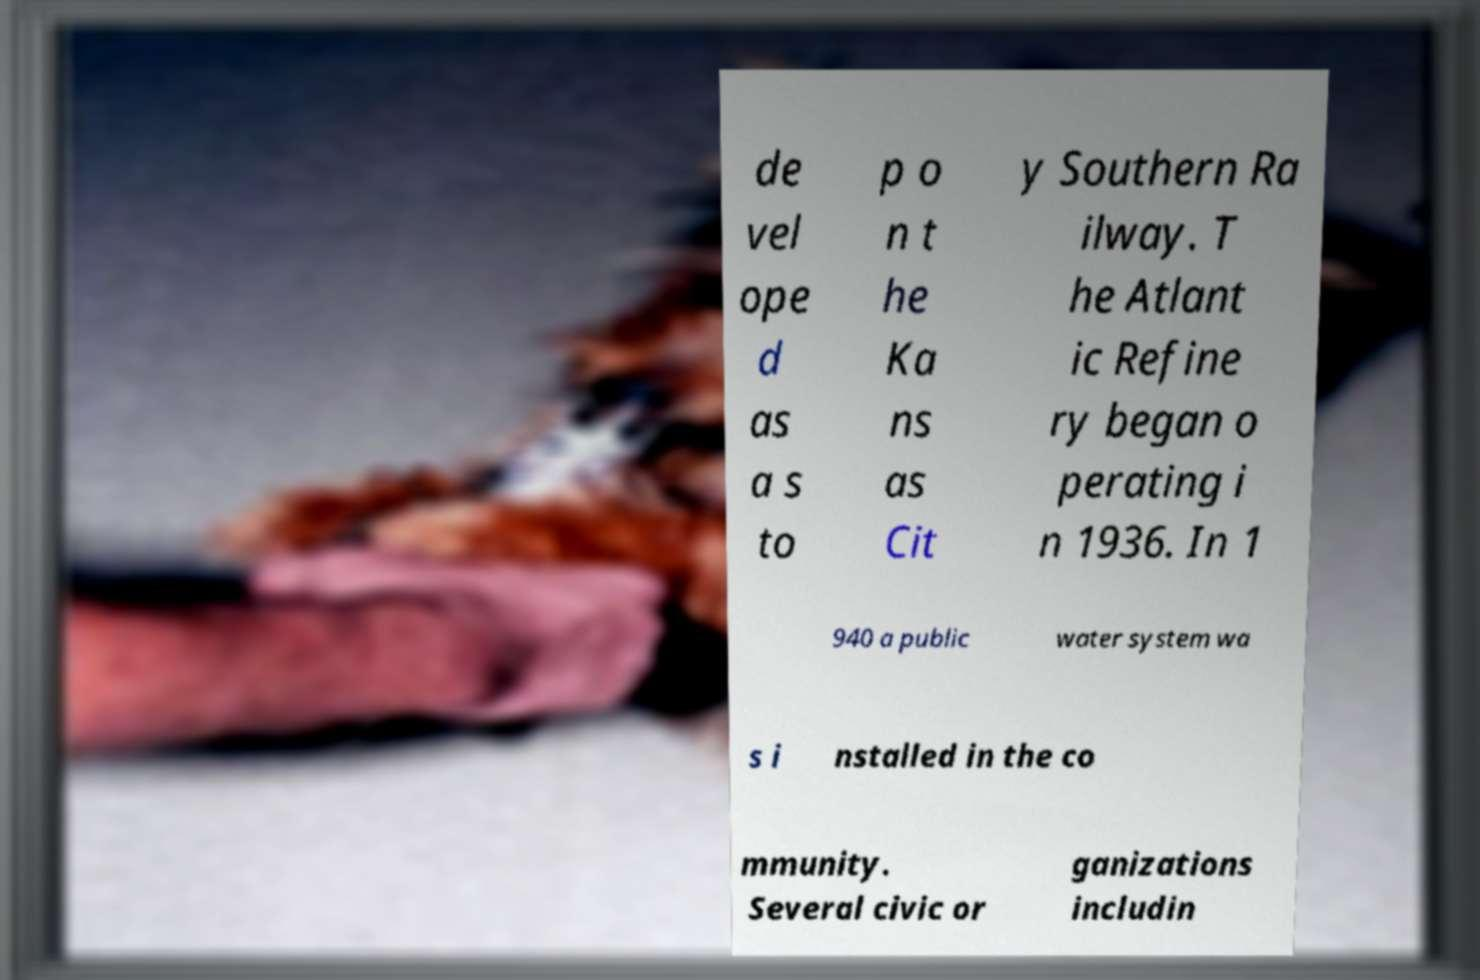Could you assist in decoding the text presented in this image and type it out clearly? de vel ope d as a s to p o n t he Ka ns as Cit y Southern Ra ilway. T he Atlant ic Refine ry began o perating i n 1936. In 1 940 a public water system wa s i nstalled in the co mmunity. Several civic or ganizations includin 